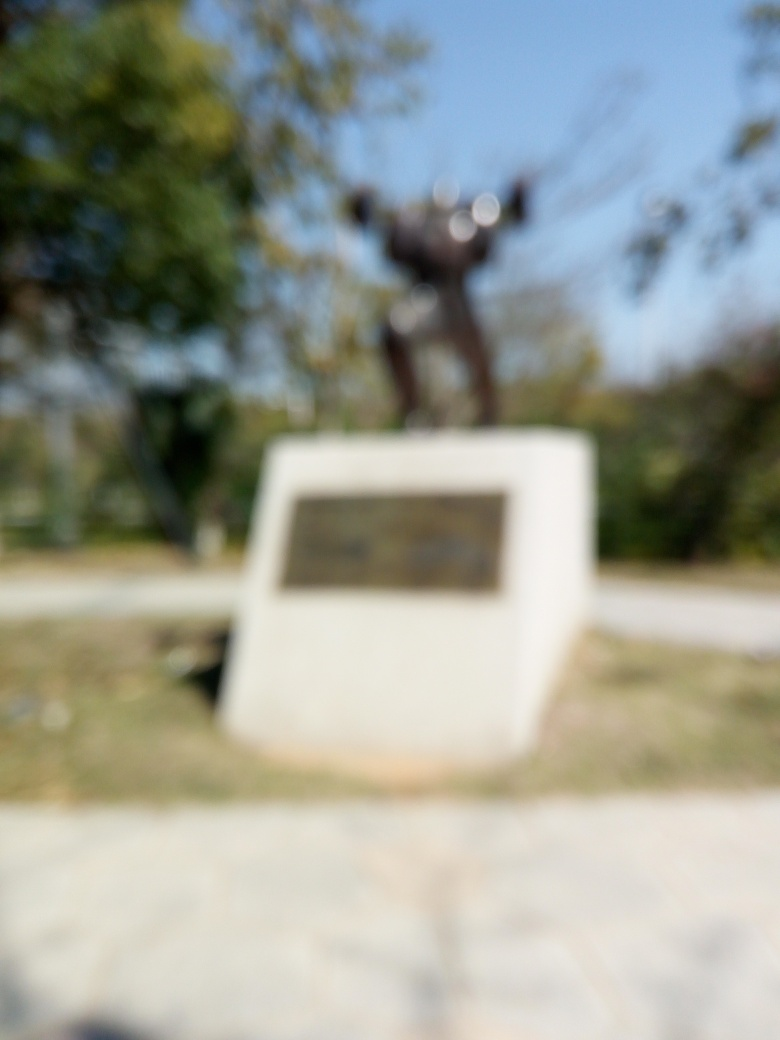Imagine a clearer version of this image. What might be happening? In a clearer version of this image, we could potentially see a commemorative statue, possibly depicting a historical or notable figure, set in a park or memorial area. The statue might be capturing a dynamic pose, suggesting action or celebration, often characteristic of monuments dedicated to achievements or important events. 